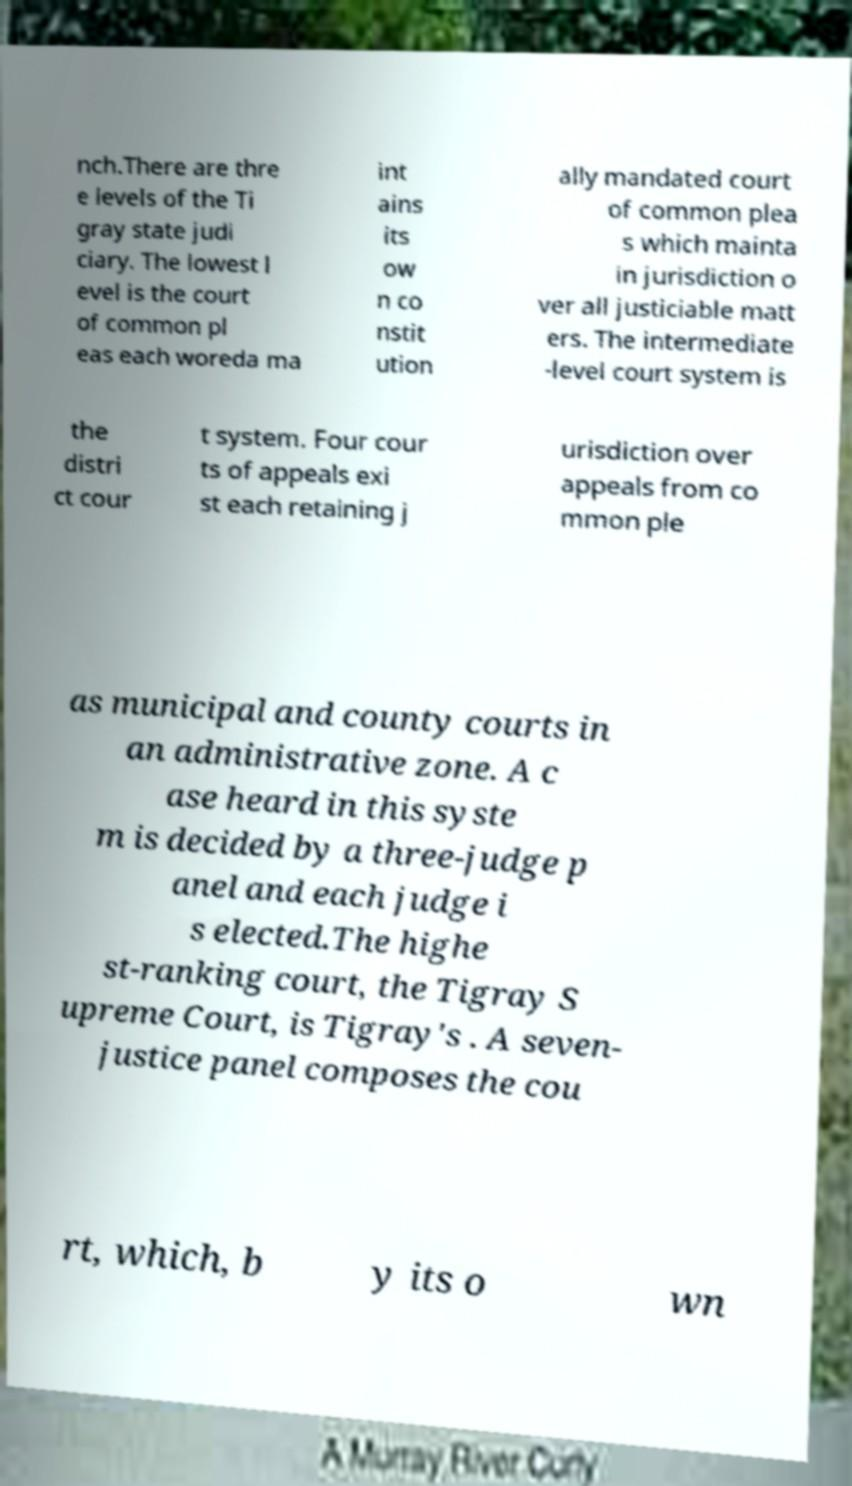Can you read and provide the text displayed in the image?This photo seems to have some interesting text. Can you extract and type it out for me? nch.There are thre e levels of the Ti gray state judi ciary. The lowest l evel is the court of common pl eas each woreda ma int ains its ow n co nstit ution ally mandated court of common plea s which mainta in jurisdiction o ver all justiciable matt ers. The intermediate -level court system is the distri ct cour t system. Four cour ts of appeals exi st each retaining j urisdiction over appeals from co mmon ple as municipal and county courts in an administrative zone. A c ase heard in this syste m is decided by a three-judge p anel and each judge i s elected.The highe st-ranking court, the Tigray S upreme Court, is Tigray's . A seven- justice panel composes the cou rt, which, b y its o wn 